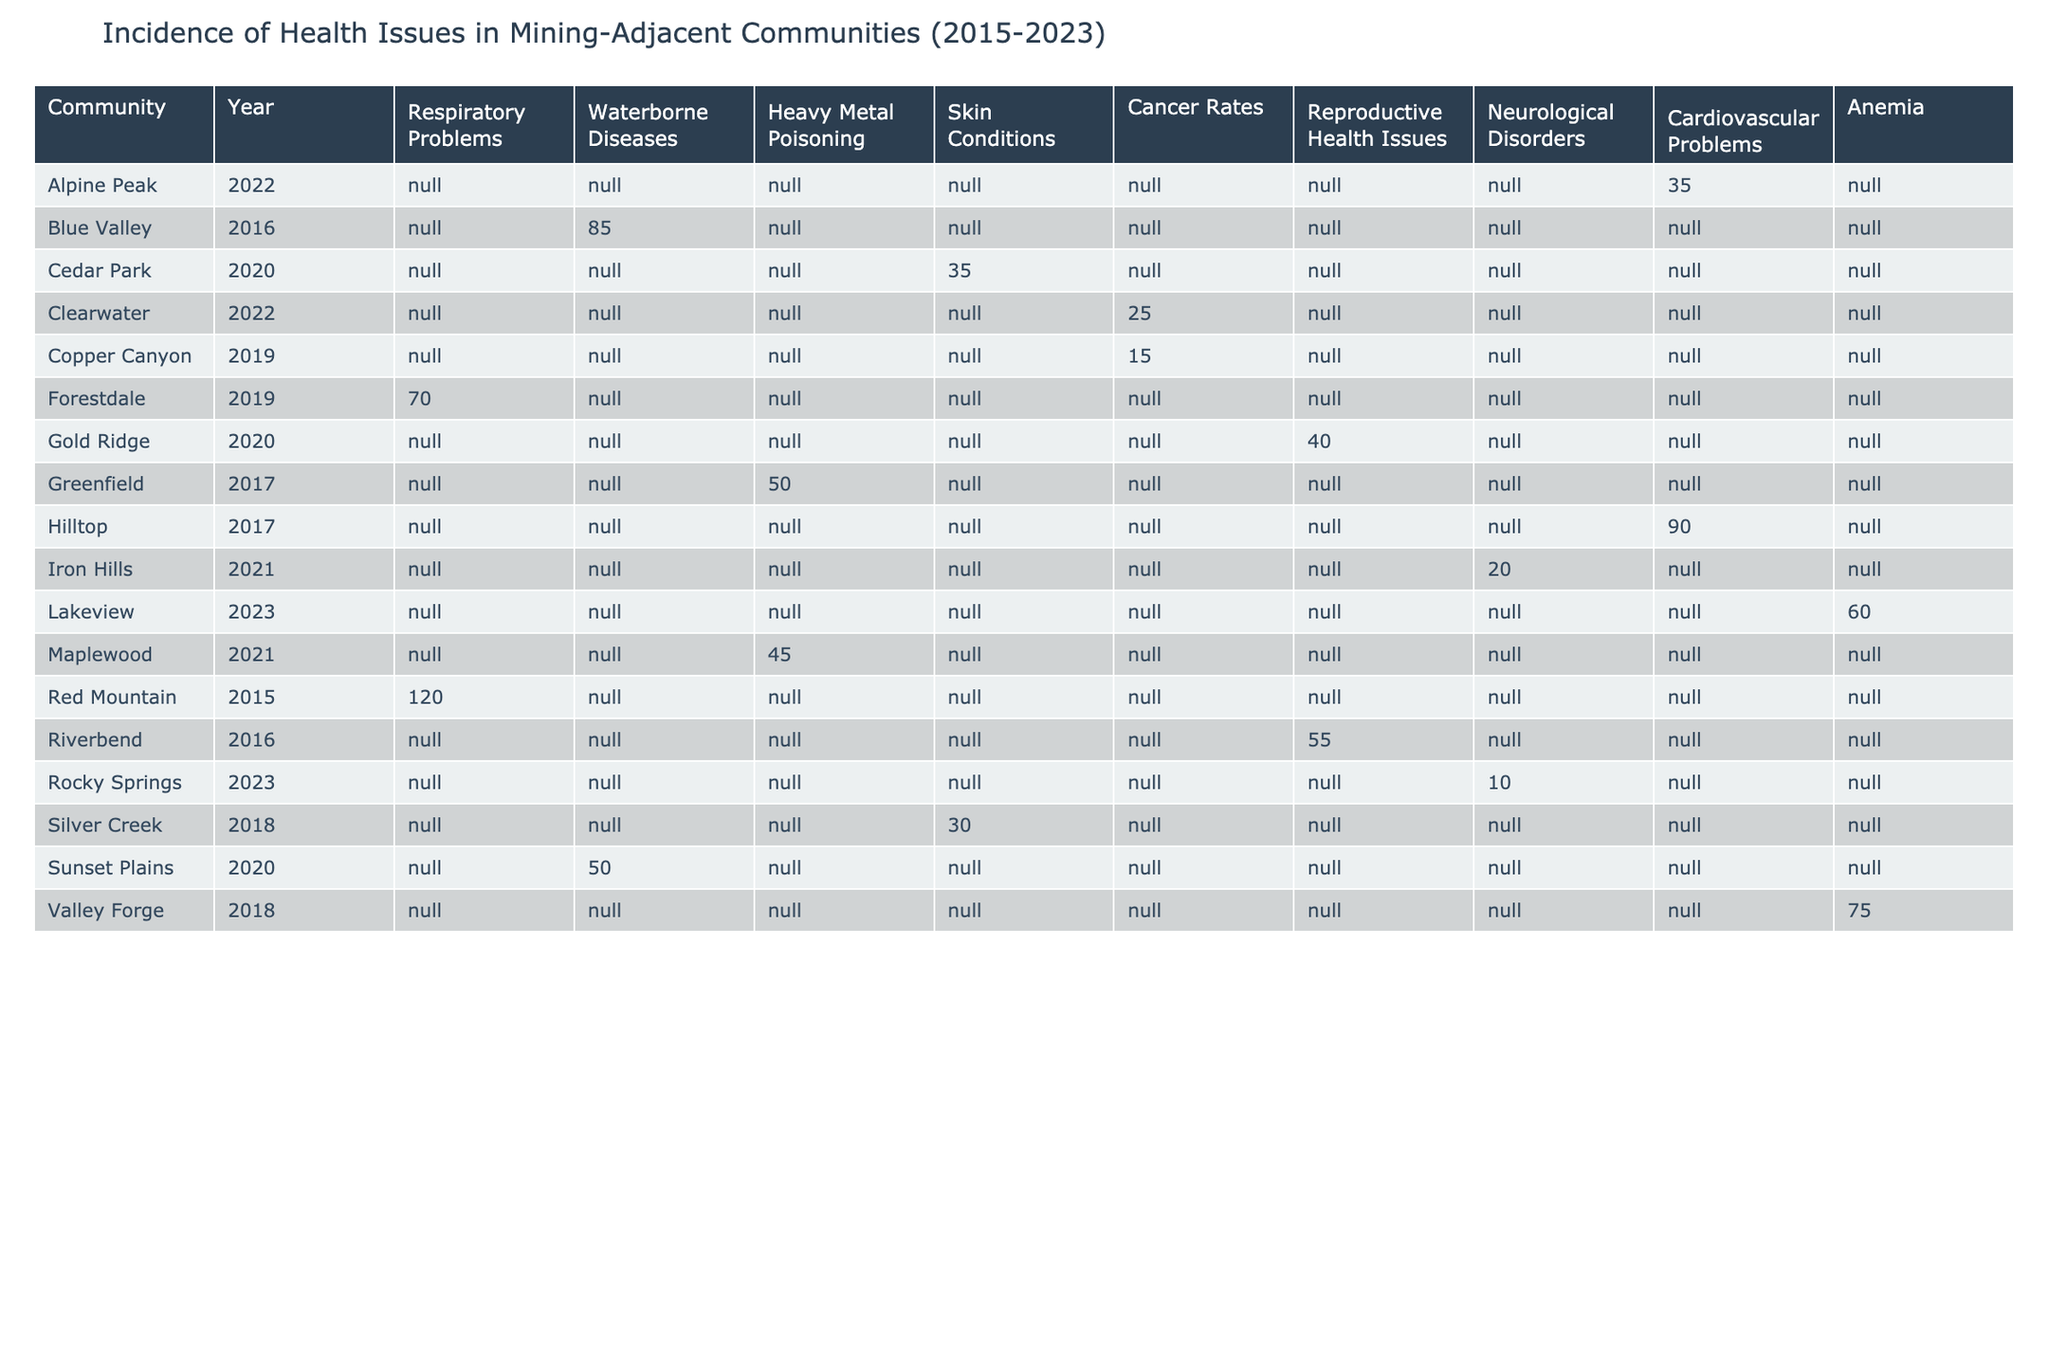What health issue was reported by the Copper Canyon community in 2019? According to the table, the health issue reported by Copper Canyon in 2019 is Cancer Rates.
Answer: Cancer Rates Which community reported the highest number of cases for Respiratory Problems? By examining the table, Forestdale reported 70 cases of Respiratory Problems, which is the highest among the communities listed.
Answer: Forestdale How many reported cases of Neurological Disorders were there in total from 2021 to 2023? The reported cases of Neurological Disorders are 20 in 2021, 10 in 2023. Thus, the total is 20 + 10 = 30.
Answer: 30 Was there a community that reported Waterborne Diseases in 2022? No community reported Waterborne Diseases in 2022, as the table shows that this health issue was reported only in 2016 and 2020.
Answer: No What is the average number of reported cases for Skin Conditions across all years? The reported cases of Skin Conditions from the table are 30 (2018, Silver Creek), 35 (2020, Cedar Park). Summing these gives 30 + 35 = 65. The number of instances is 2, so the average is 65 / 2 = 32.5.
Answer: 32.5 In how many years was Anemia reported, and what was the total number of cases? Anemia was reported in 2022 (75 cases in Valley Forge) and 2023 (60 cases in Lakeview), which is a total of 2 years. The total cases is 75 + 60 = 135.
Answer: 2 years, 135 cases What is the difference in reported cases of Heavy Metal Poisoning between 2017 and 2021? Heavy Metal Poisoning was reported with 50 cases in 2017 (Greenfield) and 45 cases in 2021 (Maplewood). The difference is 50 - 45 = 5.
Answer: 5 Which year had the most diverse range of health issues reported? In looking at the years, 2020 shows reports for 3 distinct health issues: Reproductive Health Issues, Skin Conditions, and Waterborne Diseases. It has maximum diversity compared to other years.
Answer: 2020 Was there an increase in the number of cancer rate cases reported from 2018 to 2019? The table shows that Cancer Rates were reported in Copper Canyon in 2019 with 15 cases and were not reported in 2018. The increase is from 0 to 15, indicating a rise.
Answer: Yes Which community had the highest number of reported cases in 2020? Reviewing the table, Sunset Plains had 50 cases of Waterborne Diseases in 2020, which is the highest reported cases for that year.
Answer: Sunset Plains 